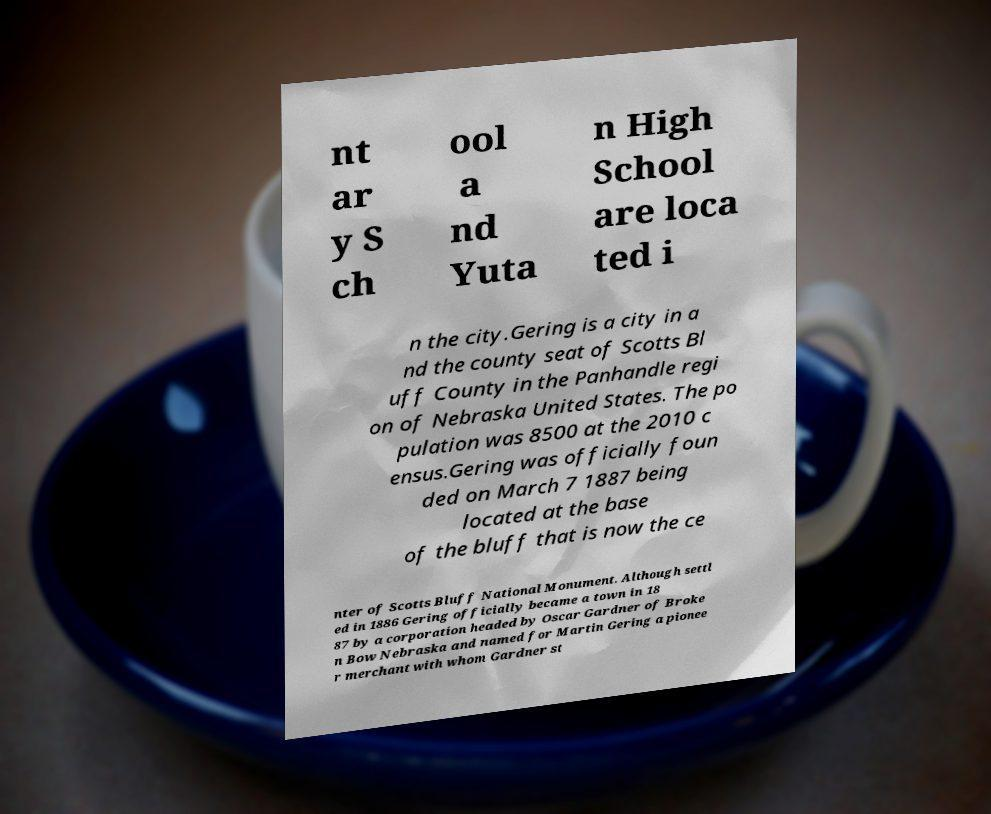Could you assist in decoding the text presented in this image and type it out clearly? nt ar y S ch ool a nd Yuta n High School are loca ted i n the city.Gering is a city in a nd the county seat of Scotts Bl uff County in the Panhandle regi on of Nebraska United States. The po pulation was 8500 at the 2010 c ensus.Gering was officially foun ded on March 7 1887 being located at the base of the bluff that is now the ce nter of Scotts Bluff National Monument. Although settl ed in 1886 Gering officially became a town in 18 87 by a corporation headed by Oscar Gardner of Broke n Bow Nebraska and named for Martin Gering a pionee r merchant with whom Gardner st 